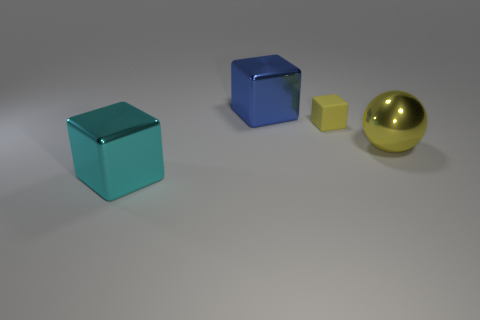What shape is the large thing that is the same color as the rubber cube?
Make the answer very short. Sphere. How many matte objects are the same size as the blue metal cube?
Your response must be concise. 0. How many yellow balls are left of the small object?
Provide a short and direct response. 0. What is the material of the object left of the large metal cube that is behind the big cyan thing?
Offer a terse response. Metal. Is there a small matte object that has the same color as the tiny block?
Your answer should be compact. No. There is a yellow sphere that is the same material as the large cyan object; what is its size?
Your response must be concise. Large. Are there any other things that have the same color as the tiny rubber object?
Give a very brief answer. Yes. The big metal block on the right side of the large cyan shiny cube is what color?
Ensure brevity in your answer.  Blue. There is a large object on the left side of the big metal cube behind the small yellow matte cube; is there a large blue shiny block left of it?
Give a very brief answer. No. Are there more large cyan metal objects behind the small yellow block than purple matte objects?
Provide a succinct answer. No. 